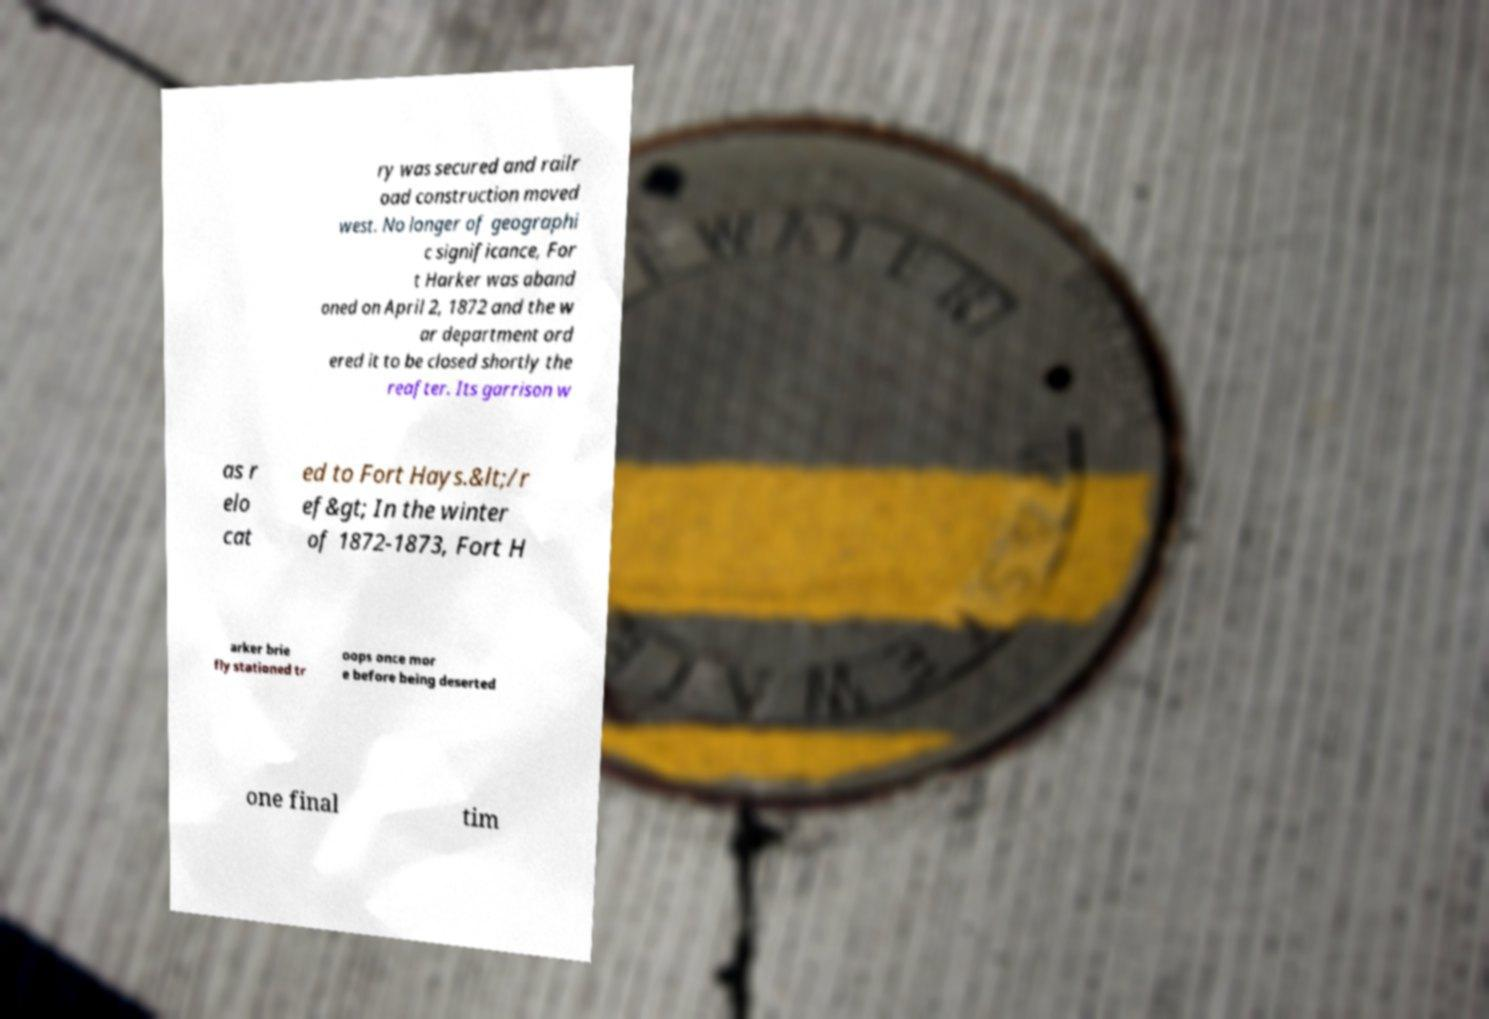Could you assist in decoding the text presented in this image and type it out clearly? ry was secured and railr oad construction moved west. No longer of geographi c significance, For t Harker was aband oned on April 2, 1872 and the w ar department ord ered it to be closed shortly the reafter. Its garrison w as r elo cat ed to Fort Hays.&lt;/r ef&gt; In the winter of 1872-1873, Fort H arker brie fly stationed tr oops once mor e before being deserted one final tim 